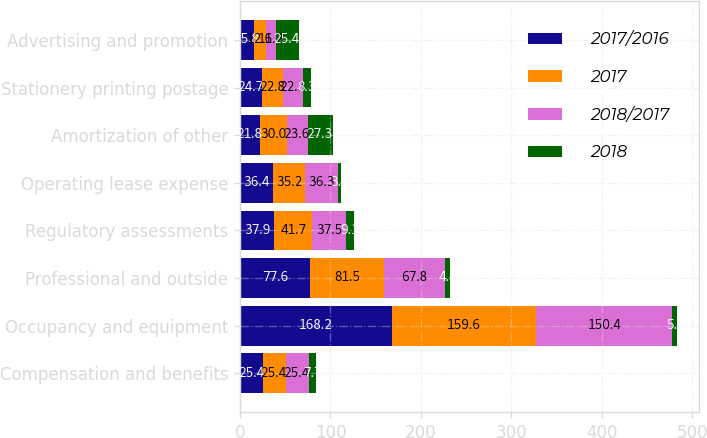Convert chart. <chart><loc_0><loc_0><loc_500><loc_500><stacked_bar_chart><ecel><fcel>Compensation and benefits<fcel>Occupancy and equipment<fcel>Professional and outside<fcel>Regulatory assessments<fcel>Operating lease expense<fcel>Amortization of other<fcel>Stationery printing postage<fcel>Advertising and promotion<nl><fcel>2017/2016<fcel>25.4<fcel>168.2<fcel>77.6<fcel>37.9<fcel>36.4<fcel>21.8<fcel>24.7<fcel>15.8<nl><fcel>2017<fcel>25.4<fcel>159.6<fcel>81.5<fcel>41.7<fcel>35.2<fcel>30<fcel>22.8<fcel>12.6<nl><fcel>2018/2017<fcel>25.4<fcel>150.4<fcel>67.8<fcel>37.5<fcel>36.3<fcel>23.6<fcel>22.3<fcel>11.2<nl><fcel>2018<fcel>7.7<fcel>5.4<fcel>4.8<fcel>9.1<fcel>3.4<fcel>27.3<fcel>8.3<fcel>25.4<nl></chart> 